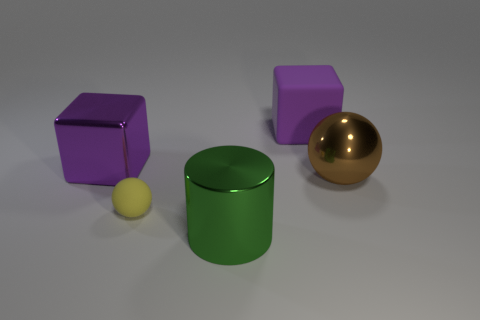Add 3 cyan rubber objects. How many objects exist? 8 Subtract all spheres. How many objects are left? 3 Add 1 large metallic blocks. How many large metallic blocks are left? 2 Add 3 large cubes. How many large cubes exist? 5 Subtract 1 green cylinders. How many objects are left? 4 Subtract all matte balls. Subtract all big metal cylinders. How many objects are left? 3 